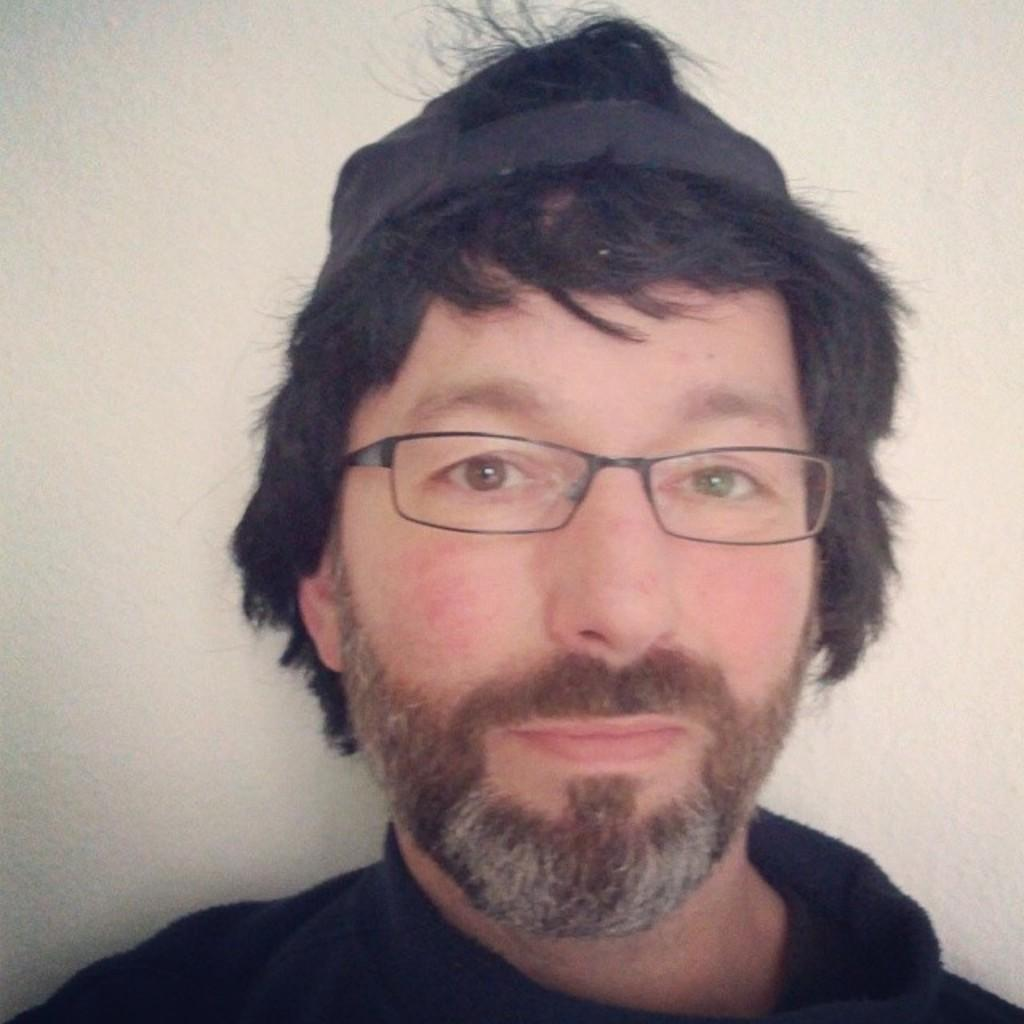Who is present in the image? There is a man in the image. What is the man wearing? The man is wearing a black dress, spectacles, and a cap on his head. What is the man doing in the image? The man is looking at a picture. What can be seen behind the man? There is a wall visible at the back of the man. What type of wood is the man using to calm his nerves in the image? There is no wood or mention of nerves in the image; the man is simply looking at a picture. 